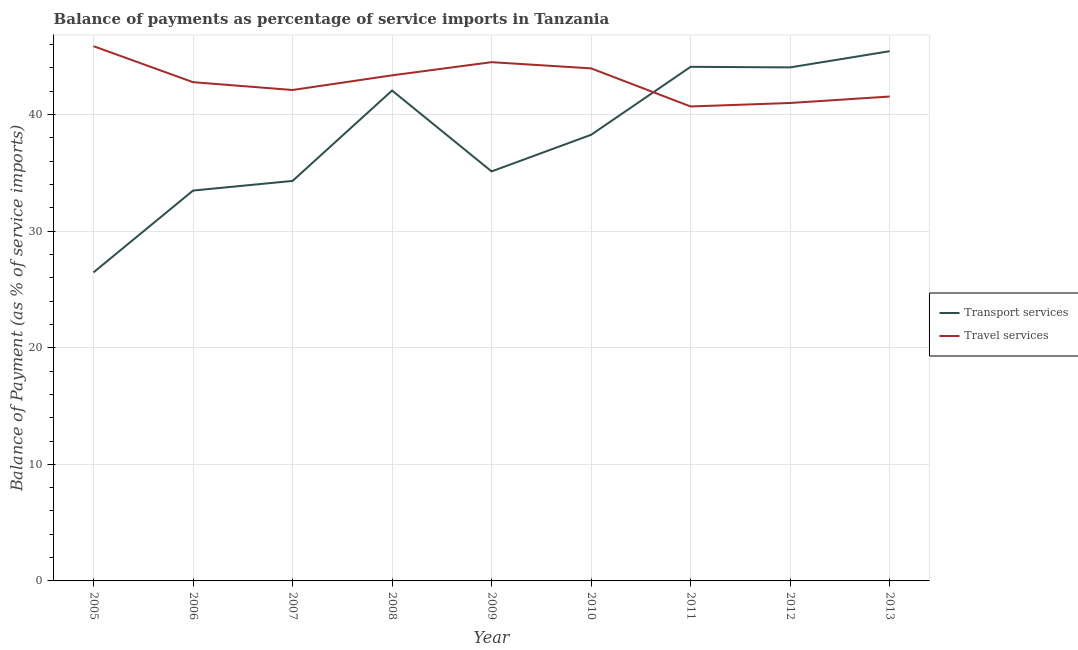Does the line corresponding to balance of payments of transport services intersect with the line corresponding to balance of payments of travel services?
Keep it short and to the point. Yes. Is the number of lines equal to the number of legend labels?
Give a very brief answer. Yes. What is the balance of payments of travel services in 2012?
Offer a very short reply. 40.99. Across all years, what is the maximum balance of payments of transport services?
Provide a short and direct response. 45.44. Across all years, what is the minimum balance of payments of transport services?
Ensure brevity in your answer.  26.47. In which year was the balance of payments of travel services maximum?
Ensure brevity in your answer.  2005. In which year was the balance of payments of transport services minimum?
Your answer should be compact. 2005. What is the total balance of payments of transport services in the graph?
Offer a terse response. 343.3. What is the difference between the balance of payments of transport services in 2007 and that in 2013?
Keep it short and to the point. -11.13. What is the difference between the balance of payments of transport services in 2007 and the balance of payments of travel services in 2011?
Your answer should be compact. -6.39. What is the average balance of payments of travel services per year?
Ensure brevity in your answer.  42.87. In the year 2011, what is the difference between the balance of payments of transport services and balance of payments of travel services?
Provide a short and direct response. 3.4. What is the ratio of the balance of payments of travel services in 2012 to that in 2013?
Give a very brief answer. 0.99. Is the balance of payments of travel services in 2011 less than that in 2013?
Offer a very short reply. Yes. Is the difference between the balance of payments of travel services in 2011 and 2013 greater than the difference between the balance of payments of transport services in 2011 and 2013?
Keep it short and to the point. Yes. What is the difference between the highest and the second highest balance of payments of transport services?
Your answer should be compact. 1.34. What is the difference between the highest and the lowest balance of payments of transport services?
Your answer should be very brief. 18.97. In how many years, is the balance of payments of travel services greater than the average balance of payments of travel services taken over all years?
Make the answer very short. 4. What is the difference between two consecutive major ticks on the Y-axis?
Offer a very short reply. 10. Does the graph contain any zero values?
Your answer should be very brief. No. Does the graph contain grids?
Keep it short and to the point. Yes. How many legend labels are there?
Provide a succinct answer. 2. What is the title of the graph?
Give a very brief answer. Balance of payments as percentage of service imports in Tanzania. Does "Unregistered firms" appear as one of the legend labels in the graph?
Provide a short and direct response. No. What is the label or title of the Y-axis?
Offer a terse response. Balance of Payment (as % of service imports). What is the Balance of Payment (as % of service imports) in Transport services in 2005?
Offer a terse response. 26.47. What is the Balance of Payment (as % of service imports) in Travel services in 2005?
Offer a very short reply. 45.87. What is the Balance of Payment (as % of service imports) in Transport services in 2006?
Your answer should be compact. 33.48. What is the Balance of Payment (as % of service imports) of Travel services in 2006?
Make the answer very short. 42.78. What is the Balance of Payment (as % of service imports) in Transport services in 2007?
Offer a terse response. 34.31. What is the Balance of Payment (as % of service imports) in Travel services in 2007?
Your answer should be very brief. 42.11. What is the Balance of Payment (as % of service imports) in Transport services in 2008?
Make the answer very short. 42.06. What is the Balance of Payment (as % of service imports) of Travel services in 2008?
Provide a succinct answer. 43.37. What is the Balance of Payment (as % of service imports) of Transport services in 2009?
Keep it short and to the point. 35.13. What is the Balance of Payment (as % of service imports) in Travel services in 2009?
Your answer should be very brief. 44.5. What is the Balance of Payment (as % of service imports) in Transport services in 2010?
Your answer should be very brief. 38.27. What is the Balance of Payment (as % of service imports) of Travel services in 2010?
Give a very brief answer. 43.96. What is the Balance of Payment (as % of service imports) of Transport services in 2011?
Ensure brevity in your answer.  44.1. What is the Balance of Payment (as % of service imports) of Travel services in 2011?
Provide a succinct answer. 40.7. What is the Balance of Payment (as % of service imports) of Transport services in 2012?
Your answer should be compact. 44.05. What is the Balance of Payment (as % of service imports) in Travel services in 2012?
Give a very brief answer. 40.99. What is the Balance of Payment (as % of service imports) in Transport services in 2013?
Your answer should be very brief. 45.44. What is the Balance of Payment (as % of service imports) in Travel services in 2013?
Your answer should be very brief. 41.55. Across all years, what is the maximum Balance of Payment (as % of service imports) in Transport services?
Your answer should be very brief. 45.44. Across all years, what is the maximum Balance of Payment (as % of service imports) of Travel services?
Your answer should be very brief. 45.87. Across all years, what is the minimum Balance of Payment (as % of service imports) of Transport services?
Keep it short and to the point. 26.47. Across all years, what is the minimum Balance of Payment (as % of service imports) in Travel services?
Provide a short and direct response. 40.7. What is the total Balance of Payment (as % of service imports) in Transport services in the graph?
Give a very brief answer. 343.3. What is the total Balance of Payment (as % of service imports) in Travel services in the graph?
Make the answer very short. 385.82. What is the difference between the Balance of Payment (as % of service imports) of Transport services in 2005 and that in 2006?
Your answer should be very brief. -7.02. What is the difference between the Balance of Payment (as % of service imports) in Travel services in 2005 and that in 2006?
Offer a terse response. 3.09. What is the difference between the Balance of Payment (as % of service imports) of Transport services in 2005 and that in 2007?
Ensure brevity in your answer.  -7.84. What is the difference between the Balance of Payment (as % of service imports) of Travel services in 2005 and that in 2007?
Your response must be concise. 3.76. What is the difference between the Balance of Payment (as % of service imports) of Transport services in 2005 and that in 2008?
Offer a very short reply. -15.6. What is the difference between the Balance of Payment (as % of service imports) of Travel services in 2005 and that in 2008?
Keep it short and to the point. 2.5. What is the difference between the Balance of Payment (as % of service imports) of Transport services in 2005 and that in 2009?
Your answer should be compact. -8.66. What is the difference between the Balance of Payment (as % of service imports) of Travel services in 2005 and that in 2009?
Provide a short and direct response. 1.37. What is the difference between the Balance of Payment (as % of service imports) of Transport services in 2005 and that in 2010?
Make the answer very short. -11.8. What is the difference between the Balance of Payment (as % of service imports) of Travel services in 2005 and that in 2010?
Your response must be concise. 1.9. What is the difference between the Balance of Payment (as % of service imports) in Transport services in 2005 and that in 2011?
Keep it short and to the point. -17.63. What is the difference between the Balance of Payment (as % of service imports) in Travel services in 2005 and that in 2011?
Provide a succinct answer. 5.17. What is the difference between the Balance of Payment (as % of service imports) of Transport services in 2005 and that in 2012?
Provide a succinct answer. -17.58. What is the difference between the Balance of Payment (as % of service imports) of Travel services in 2005 and that in 2012?
Make the answer very short. 4.87. What is the difference between the Balance of Payment (as % of service imports) in Transport services in 2005 and that in 2013?
Offer a terse response. -18.97. What is the difference between the Balance of Payment (as % of service imports) in Travel services in 2005 and that in 2013?
Ensure brevity in your answer.  4.32. What is the difference between the Balance of Payment (as % of service imports) in Transport services in 2006 and that in 2007?
Provide a short and direct response. -0.83. What is the difference between the Balance of Payment (as % of service imports) in Travel services in 2006 and that in 2007?
Your answer should be very brief. 0.67. What is the difference between the Balance of Payment (as % of service imports) of Transport services in 2006 and that in 2008?
Make the answer very short. -8.58. What is the difference between the Balance of Payment (as % of service imports) in Travel services in 2006 and that in 2008?
Provide a short and direct response. -0.59. What is the difference between the Balance of Payment (as % of service imports) in Transport services in 2006 and that in 2009?
Give a very brief answer. -1.64. What is the difference between the Balance of Payment (as % of service imports) of Travel services in 2006 and that in 2009?
Offer a very short reply. -1.72. What is the difference between the Balance of Payment (as % of service imports) of Transport services in 2006 and that in 2010?
Offer a terse response. -4.78. What is the difference between the Balance of Payment (as % of service imports) of Travel services in 2006 and that in 2010?
Your answer should be compact. -1.18. What is the difference between the Balance of Payment (as % of service imports) in Transport services in 2006 and that in 2011?
Provide a short and direct response. -10.61. What is the difference between the Balance of Payment (as % of service imports) in Travel services in 2006 and that in 2011?
Give a very brief answer. 2.08. What is the difference between the Balance of Payment (as % of service imports) in Transport services in 2006 and that in 2012?
Keep it short and to the point. -10.56. What is the difference between the Balance of Payment (as % of service imports) in Travel services in 2006 and that in 2012?
Your answer should be very brief. 1.78. What is the difference between the Balance of Payment (as % of service imports) in Transport services in 2006 and that in 2013?
Ensure brevity in your answer.  -11.95. What is the difference between the Balance of Payment (as % of service imports) of Travel services in 2006 and that in 2013?
Your answer should be very brief. 1.23. What is the difference between the Balance of Payment (as % of service imports) of Transport services in 2007 and that in 2008?
Your answer should be compact. -7.75. What is the difference between the Balance of Payment (as % of service imports) of Travel services in 2007 and that in 2008?
Your response must be concise. -1.26. What is the difference between the Balance of Payment (as % of service imports) in Transport services in 2007 and that in 2009?
Your response must be concise. -0.82. What is the difference between the Balance of Payment (as % of service imports) in Travel services in 2007 and that in 2009?
Your answer should be compact. -2.39. What is the difference between the Balance of Payment (as % of service imports) of Transport services in 2007 and that in 2010?
Your response must be concise. -3.96. What is the difference between the Balance of Payment (as % of service imports) of Travel services in 2007 and that in 2010?
Your response must be concise. -1.85. What is the difference between the Balance of Payment (as % of service imports) of Transport services in 2007 and that in 2011?
Your response must be concise. -9.79. What is the difference between the Balance of Payment (as % of service imports) in Travel services in 2007 and that in 2011?
Provide a short and direct response. 1.41. What is the difference between the Balance of Payment (as % of service imports) in Transport services in 2007 and that in 2012?
Your answer should be compact. -9.74. What is the difference between the Balance of Payment (as % of service imports) of Travel services in 2007 and that in 2012?
Your response must be concise. 1.11. What is the difference between the Balance of Payment (as % of service imports) in Transport services in 2007 and that in 2013?
Your answer should be compact. -11.13. What is the difference between the Balance of Payment (as % of service imports) of Travel services in 2007 and that in 2013?
Provide a succinct answer. 0.56. What is the difference between the Balance of Payment (as % of service imports) in Transport services in 2008 and that in 2009?
Ensure brevity in your answer.  6.94. What is the difference between the Balance of Payment (as % of service imports) of Travel services in 2008 and that in 2009?
Offer a very short reply. -1.13. What is the difference between the Balance of Payment (as % of service imports) of Transport services in 2008 and that in 2010?
Give a very brief answer. 3.8. What is the difference between the Balance of Payment (as % of service imports) in Travel services in 2008 and that in 2010?
Offer a terse response. -0.6. What is the difference between the Balance of Payment (as % of service imports) of Transport services in 2008 and that in 2011?
Provide a succinct answer. -2.03. What is the difference between the Balance of Payment (as % of service imports) of Travel services in 2008 and that in 2011?
Offer a very short reply. 2.67. What is the difference between the Balance of Payment (as % of service imports) of Transport services in 2008 and that in 2012?
Offer a terse response. -1.98. What is the difference between the Balance of Payment (as % of service imports) of Travel services in 2008 and that in 2012?
Give a very brief answer. 2.37. What is the difference between the Balance of Payment (as % of service imports) in Transport services in 2008 and that in 2013?
Ensure brevity in your answer.  -3.37. What is the difference between the Balance of Payment (as % of service imports) of Travel services in 2008 and that in 2013?
Ensure brevity in your answer.  1.82. What is the difference between the Balance of Payment (as % of service imports) of Transport services in 2009 and that in 2010?
Make the answer very short. -3.14. What is the difference between the Balance of Payment (as % of service imports) in Travel services in 2009 and that in 2010?
Make the answer very short. 0.53. What is the difference between the Balance of Payment (as % of service imports) in Transport services in 2009 and that in 2011?
Provide a succinct answer. -8.97. What is the difference between the Balance of Payment (as % of service imports) of Travel services in 2009 and that in 2011?
Ensure brevity in your answer.  3.8. What is the difference between the Balance of Payment (as % of service imports) in Transport services in 2009 and that in 2012?
Provide a short and direct response. -8.92. What is the difference between the Balance of Payment (as % of service imports) of Travel services in 2009 and that in 2012?
Give a very brief answer. 3.5. What is the difference between the Balance of Payment (as % of service imports) in Transport services in 2009 and that in 2013?
Ensure brevity in your answer.  -10.31. What is the difference between the Balance of Payment (as % of service imports) in Travel services in 2009 and that in 2013?
Keep it short and to the point. 2.95. What is the difference between the Balance of Payment (as % of service imports) in Transport services in 2010 and that in 2011?
Make the answer very short. -5.83. What is the difference between the Balance of Payment (as % of service imports) of Travel services in 2010 and that in 2011?
Provide a short and direct response. 3.27. What is the difference between the Balance of Payment (as % of service imports) in Transport services in 2010 and that in 2012?
Ensure brevity in your answer.  -5.78. What is the difference between the Balance of Payment (as % of service imports) of Travel services in 2010 and that in 2012?
Your answer should be compact. 2.97. What is the difference between the Balance of Payment (as % of service imports) of Transport services in 2010 and that in 2013?
Give a very brief answer. -7.17. What is the difference between the Balance of Payment (as % of service imports) of Travel services in 2010 and that in 2013?
Make the answer very short. 2.42. What is the difference between the Balance of Payment (as % of service imports) of Transport services in 2011 and that in 2012?
Your response must be concise. 0.05. What is the difference between the Balance of Payment (as % of service imports) of Travel services in 2011 and that in 2012?
Your response must be concise. -0.3. What is the difference between the Balance of Payment (as % of service imports) in Transport services in 2011 and that in 2013?
Make the answer very short. -1.34. What is the difference between the Balance of Payment (as % of service imports) in Travel services in 2011 and that in 2013?
Make the answer very short. -0.85. What is the difference between the Balance of Payment (as % of service imports) of Transport services in 2012 and that in 2013?
Offer a very short reply. -1.39. What is the difference between the Balance of Payment (as % of service imports) of Travel services in 2012 and that in 2013?
Offer a terse response. -0.55. What is the difference between the Balance of Payment (as % of service imports) of Transport services in 2005 and the Balance of Payment (as % of service imports) of Travel services in 2006?
Your response must be concise. -16.31. What is the difference between the Balance of Payment (as % of service imports) in Transport services in 2005 and the Balance of Payment (as % of service imports) in Travel services in 2007?
Your answer should be compact. -15.64. What is the difference between the Balance of Payment (as % of service imports) in Transport services in 2005 and the Balance of Payment (as % of service imports) in Travel services in 2008?
Provide a short and direct response. -16.9. What is the difference between the Balance of Payment (as % of service imports) of Transport services in 2005 and the Balance of Payment (as % of service imports) of Travel services in 2009?
Ensure brevity in your answer.  -18.03. What is the difference between the Balance of Payment (as % of service imports) in Transport services in 2005 and the Balance of Payment (as % of service imports) in Travel services in 2010?
Make the answer very short. -17.5. What is the difference between the Balance of Payment (as % of service imports) in Transport services in 2005 and the Balance of Payment (as % of service imports) in Travel services in 2011?
Offer a very short reply. -14.23. What is the difference between the Balance of Payment (as % of service imports) of Transport services in 2005 and the Balance of Payment (as % of service imports) of Travel services in 2012?
Provide a succinct answer. -14.53. What is the difference between the Balance of Payment (as % of service imports) in Transport services in 2005 and the Balance of Payment (as % of service imports) in Travel services in 2013?
Keep it short and to the point. -15.08. What is the difference between the Balance of Payment (as % of service imports) in Transport services in 2006 and the Balance of Payment (as % of service imports) in Travel services in 2007?
Offer a terse response. -8.63. What is the difference between the Balance of Payment (as % of service imports) in Transport services in 2006 and the Balance of Payment (as % of service imports) in Travel services in 2008?
Your answer should be very brief. -9.88. What is the difference between the Balance of Payment (as % of service imports) in Transport services in 2006 and the Balance of Payment (as % of service imports) in Travel services in 2009?
Your response must be concise. -11.01. What is the difference between the Balance of Payment (as % of service imports) of Transport services in 2006 and the Balance of Payment (as % of service imports) of Travel services in 2010?
Provide a short and direct response. -10.48. What is the difference between the Balance of Payment (as % of service imports) of Transport services in 2006 and the Balance of Payment (as % of service imports) of Travel services in 2011?
Make the answer very short. -7.21. What is the difference between the Balance of Payment (as % of service imports) of Transport services in 2006 and the Balance of Payment (as % of service imports) of Travel services in 2012?
Offer a terse response. -7.51. What is the difference between the Balance of Payment (as % of service imports) in Transport services in 2006 and the Balance of Payment (as % of service imports) in Travel services in 2013?
Your answer should be compact. -8.07. What is the difference between the Balance of Payment (as % of service imports) in Transport services in 2007 and the Balance of Payment (as % of service imports) in Travel services in 2008?
Keep it short and to the point. -9.06. What is the difference between the Balance of Payment (as % of service imports) in Transport services in 2007 and the Balance of Payment (as % of service imports) in Travel services in 2009?
Your response must be concise. -10.19. What is the difference between the Balance of Payment (as % of service imports) of Transport services in 2007 and the Balance of Payment (as % of service imports) of Travel services in 2010?
Keep it short and to the point. -9.65. What is the difference between the Balance of Payment (as % of service imports) of Transport services in 2007 and the Balance of Payment (as % of service imports) of Travel services in 2011?
Keep it short and to the point. -6.39. What is the difference between the Balance of Payment (as % of service imports) in Transport services in 2007 and the Balance of Payment (as % of service imports) in Travel services in 2012?
Provide a succinct answer. -6.68. What is the difference between the Balance of Payment (as % of service imports) in Transport services in 2007 and the Balance of Payment (as % of service imports) in Travel services in 2013?
Provide a succinct answer. -7.24. What is the difference between the Balance of Payment (as % of service imports) of Transport services in 2008 and the Balance of Payment (as % of service imports) of Travel services in 2009?
Offer a very short reply. -2.43. What is the difference between the Balance of Payment (as % of service imports) of Transport services in 2008 and the Balance of Payment (as % of service imports) of Travel services in 2010?
Provide a succinct answer. -1.9. What is the difference between the Balance of Payment (as % of service imports) of Transport services in 2008 and the Balance of Payment (as % of service imports) of Travel services in 2011?
Keep it short and to the point. 1.37. What is the difference between the Balance of Payment (as % of service imports) of Transport services in 2008 and the Balance of Payment (as % of service imports) of Travel services in 2012?
Give a very brief answer. 1.07. What is the difference between the Balance of Payment (as % of service imports) of Transport services in 2008 and the Balance of Payment (as % of service imports) of Travel services in 2013?
Provide a short and direct response. 0.51. What is the difference between the Balance of Payment (as % of service imports) in Transport services in 2009 and the Balance of Payment (as % of service imports) in Travel services in 2010?
Provide a succinct answer. -8.84. What is the difference between the Balance of Payment (as % of service imports) of Transport services in 2009 and the Balance of Payment (as % of service imports) of Travel services in 2011?
Offer a very short reply. -5.57. What is the difference between the Balance of Payment (as % of service imports) of Transport services in 2009 and the Balance of Payment (as % of service imports) of Travel services in 2012?
Your answer should be very brief. -5.87. What is the difference between the Balance of Payment (as % of service imports) of Transport services in 2009 and the Balance of Payment (as % of service imports) of Travel services in 2013?
Provide a short and direct response. -6.42. What is the difference between the Balance of Payment (as % of service imports) of Transport services in 2010 and the Balance of Payment (as % of service imports) of Travel services in 2011?
Your response must be concise. -2.43. What is the difference between the Balance of Payment (as % of service imports) of Transport services in 2010 and the Balance of Payment (as % of service imports) of Travel services in 2012?
Offer a terse response. -2.73. What is the difference between the Balance of Payment (as % of service imports) in Transport services in 2010 and the Balance of Payment (as % of service imports) in Travel services in 2013?
Your response must be concise. -3.28. What is the difference between the Balance of Payment (as % of service imports) in Transport services in 2011 and the Balance of Payment (as % of service imports) in Travel services in 2012?
Your answer should be compact. 3.1. What is the difference between the Balance of Payment (as % of service imports) of Transport services in 2011 and the Balance of Payment (as % of service imports) of Travel services in 2013?
Offer a very short reply. 2.55. What is the difference between the Balance of Payment (as % of service imports) in Transport services in 2012 and the Balance of Payment (as % of service imports) in Travel services in 2013?
Your answer should be compact. 2.5. What is the average Balance of Payment (as % of service imports) in Transport services per year?
Provide a succinct answer. 38.14. What is the average Balance of Payment (as % of service imports) of Travel services per year?
Keep it short and to the point. 42.87. In the year 2005, what is the difference between the Balance of Payment (as % of service imports) of Transport services and Balance of Payment (as % of service imports) of Travel services?
Provide a succinct answer. -19.4. In the year 2006, what is the difference between the Balance of Payment (as % of service imports) of Transport services and Balance of Payment (as % of service imports) of Travel services?
Your answer should be very brief. -9.3. In the year 2007, what is the difference between the Balance of Payment (as % of service imports) of Transport services and Balance of Payment (as % of service imports) of Travel services?
Your answer should be compact. -7.8. In the year 2008, what is the difference between the Balance of Payment (as % of service imports) in Transport services and Balance of Payment (as % of service imports) in Travel services?
Offer a very short reply. -1.3. In the year 2009, what is the difference between the Balance of Payment (as % of service imports) of Transport services and Balance of Payment (as % of service imports) of Travel services?
Your answer should be very brief. -9.37. In the year 2010, what is the difference between the Balance of Payment (as % of service imports) of Transport services and Balance of Payment (as % of service imports) of Travel services?
Offer a very short reply. -5.7. In the year 2011, what is the difference between the Balance of Payment (as % of service imports) of Transport services and Balance of Payment (as % of service imports) of Travel services?
Ensure brevity in your answer.  3.4. In the year 2012, what is the difference between the Balance of Payment (as % of service imports) in Transport services and Balance of Payment (as % of service imports) in Travel services?
Keep it short and to the point. 3.05. In the year 2013, what is the difference between the Balance of Payment (as % of service imports) of Transport services and Balance of Payment (as % of service imports) of Travel services?
Provide a succinct answer. 3.89. What is the ratio of the Balance of Payment (as % of service imports) in Transport services in 2005 to that in 2006?
Keep it short and to the point. 0.79. What is the ratio of the Balance of Payment (as % of service imports) of Travel services in 2005 to that in 2006?
Your answer should be compact. 1.07. What is the ratio of the Balance of Payment (as % of service imports) of Transport services in 2005 to that in 2007?
Your answer should be compact. 0.77. What is the ratio of the Balance of Payment (as % of service imports) in Travel services in 2005 to that in 2007?
Keep it short and to the point. 1.09. What is the ratio of the Balance of Payment (as % of service imports) of Transport services in 2005 to that in 2008?
Ensure brevity in your answer.  0.63. What is the ratio of the Balance of Payment (as % of service imports) in Travel services in 2005 to that in 2008?
Give a very brief answer. 1.06. What is the ratio of the Balance of Payment (as % of service imports) of Transport services in 2005 to that in 2009?
Provide a succinct answer. 0.75. What is the ratio of the Balance of Payment (as % of service imports) of Travel services in 2005 to that in 2009?
Your answer should be compact. 1.03. What is the ratio of the Balance of Payment (as % of service imports) of Transport services in 2005 to that in 2010?
Keep it short and to the point. 0.69. What is the ratio of the Balance of Payment (as % of service imports) in Travel services in 2005 to that in 2010?
Your answer should be compact. 1.04. What is the ratio of the Balance of Payment (as % of service imports) in Transport services in 2005 to that in 2011?
Offer a very short reply. 0.6. What is the ratio of the Balance of Payment (as % of service imports) of Travel services in 2005 to that in 2011?
Ensure brevity in your answer.  1.13. What is the ratio of the Balance of Payment (as % of service imports) of Transport services in 2005 to that in 2012?
Keep it short and to the point. 0.6. What is the ratio of the Balance of Payment (as % of service imports) of Travel services in 2005 to that in 2012?
Offer a very short reply. 1.12. What is the ratio of the Balance of Payment (as % of service imports) of Transport services in 2005 to that in 2013?
Your response must be concise. 0.58. What is the ratio of the Balance of Payment (as % of service imports) of Travel services in 2005 to that in 2013?
Give a very brief answer. 1.1. What is the ratio of the Balance of Payment (as % of service imports) of Transport services in 2006 to that in 2007?
Provide a succinct answer. 0.98. What is the ratio of the Balance of Payment (as % of service imports) in Travel services in 2006 to that in 2007?
Give a very brief answer. 1.02. What is the ratio of the Balance of Payment (as % of service imports) in Transport services in 2006 to that in 2008?
Provide a short and direct response. 0.8. What is the ratio of the Balance of Payment (as % of service imports) of Travel services in 2006 to that in 2008?
Provide a succinct answer. 0.99. What is the ratio of the Balance of Payment (as % of service imports) of Transport services in 2006 to that in 2009?
Keep it short and to the point. 0.95. What is the ratio of the Balance of Payment (as % of service imports) of Travel services in 2006 to that in 2009?
Provide a succinct answer. 0.96. What is the ratio of the Balance of Payment (as % of service imports) of Travel services in 2006 to that in 2010?
Give a very brief answer. 0.97. What is the ratio of the Balance of Payment (as % of service imports) in Transport services in 2006 to that in 2011?
Give a very brief answer. 0.76. What is the ratio of the Balance of Payment (as % of service imports) in Travel services in 2006 to that in 2011?
Keep it short and to the point. 1.05. What is the ratio of the Balance of Payment (as % of service imports) in Transport services in 2006 to that in 2012?
Provide a succinct answer. 0.76. What is the ratio of the Balance of Payment (as % of service imports) in Travel services in 2006 to that in 2012?
Offer a very short reply. 1.04. What is the ratio of the Balance of Payment (as % of service imports) of Transport services in 2006 to that in 2013?
Your response must be concise. 0.74. What is the ratio of the Balance of Payment (as % of service imports) in Travel services in 2006 to that in 2013?
Your answer should be compact. 1.03. What is the ratio of the Balance of Payment (as % of service imports) of Transport services in 2007 to that in 2008?
Ensure brevity in your answer.  0.82. What is the ratio of the Balance of Payment (as % of service imports) in Transport services in 2007 to that in 2009?
Your answer should be very brief. 0.98. What is the ratio of the Balance of Payment (as % of service imports) in Travel services in 2007 to that in 2009?
Keep it short and to the point. 0.95. What is the ratio of the Balance of Payment (as % of service imports) of Transport services in 2007 to that in 2010?
Provide a short and direct response. 0.9. What is the ratio of the Balance of Payment (as % of service imports) of Travel services in 2007 to that in 2010?
Your answer should be compact. 0.96. What is the ratio of the Balance of Payment (as % of service imports) in Transport services in 2007 to that in 2011?
Provide a succinct answer. 0.78. What is the ratio of the Balance of Payment (as % of service imports) of Travel services in 2007 to that in 2011?
Provide a short and direct response. 1.03. What is the ratio of the Balance of Payment (as % of service imports) in Transport services in 2007 to that in 2012?
Give a very brief answer. 0.78. What is the ratio of the Balance of Payment (as % of service imports) in Travel services in 2007 to that in 2012?
Give a very brief answer. 1.03. What is the ratio of the Balance of Payment (as % of service imports) in Transport services in 2007 to that in 2013?
Offer a terse response. 0.76. What is the ratio of the Balance of Payment (as % of service imports) in Travel services in 2007 to that in 2013?
Give a very brief answer. 1.01. What is the ratio of the Balance of Payment (as % of service imports) in Transport services in 2008 to that in 2009?
Make the answer very short. 1.2. What is the ratio of the Balance of Payment (as % of service imports) in Travel services in 2008 to that in 2009?
Provide a short and direct response. 0.97. What is the ratio of the Balance of Payment (as % of service imports) in Transport services in 2008 to that in 2010?
Ensure brevity in your answer.  1.1. What is the ratio of the Balance of Payment (as % of service imports) in Travel services in 2008 to that in 2010?
Offer a terse response. 0.99. What is the ratio of the Balance of Payment (as % of service imports) in Transport services in 2008 to that in 2011?
Give a very brief answer. 0.95. What is the ratio of the Balance of Payment (as % of service imports) of Travel services in 2008 to that in 2011?
Make the answer very short. 1.07. What is the ratio of the Balance of Payment (as % of service imports) in Transport services in 2008 to that in 2012?
Provide a short and direct response. 0.95. What is the ratio of the Balance of Payment (as % of service imports) of Travel services in 2008 to that in 2012?
Provide a short and direct response. 1.06. What is the ratio of the Balance of Payment (as % of service imports) of Transport services in 2008 to that in 2013?
Provide a succinct answer. 0.93. What is the ratio of the Balance of Payment (as % of service imports) of Travel services in 2008 to that in 2013?
Give a very brief answer. 1.04. What is the ratio of the Balance of Payment (as % of service imports) of Transport services in 2009 to that in 2010?
Provide a short and direct response. 0.92. What is the ratio of the Balance of Payment (as % of service imports) in Travel services in 2009 to that in 2010?
Offer a very short reply. 1.01. What is the ratio of the Balance of Payment (as % of service imports) in Transport services in 2009 to that in 2011?
Your answer should be compact. 0.8. What is the ratio of the Balance of Payment (as % of service imports) of Travel services in 2009 to that in 2011?
Provide a succinct answer. 1.09. What is the ratio of the Balance of Payment (as % of service imports) in Transport services in 2009 to that in 2012?
Provide a succinct answer. 0.8. What is the ratio of the Balance of Payment (as % of service imports) of Travel services in 2009 to that in 2012?
Make the answer very short. 1.09. What is the ratio of the Balance of Payment (as % of service imports) of Transport services in 2009 to that in 2013?
Provide a short and direct response. 0.77. What is the ratio of the Balance of Payment (as % of service imports) of Travel services in 2009 to that in 2013?
Ensure brevity in your answer.  1.07. What is the ratio of the Balance of Payment (as % of service imports) in Transport services in 2010 to that in 2011?
Ensure brevity in your answer.  0.87. What is the ratio of the Balance of Payment (as % of service imports) of Travel services in 2010 to that in 2011?
Provide a short and direct response. 1.08. What is the ratio of the Balance of Payment (as % of service imports) in Transport services in 2010 to that in 2012?
Your answer should be compact. 0.87. What is the ratio of the Balance of Payment (as % of service imports) in Travel services in 2010 to that in 2012?
Ensure brevity in your answer.  1.07. What is the ratio of the Balance of Payment (as % of service imports) in Transport services in 2010 to that in 2013?
Make the answer very short. 0.84. What is the ratio of the Balance of Payment (as % of service imports) in Travel services in 2010 to that in 2013?
Provide a succinct answer. 1.06. What is the ratio of the Balance of Payment (as % of service imports) in Travel services in 2011 to that in 2012?
Make the answer very short. 0.99. What is the ratio of the Balance of Payment (as % of service imports) in Transport services in 2011 to that in 2013?
Your answer should be very brief. 0.97. What is the ratio of the Balance of Payment (as % of service imports) of Travel services in 2011 to that in 2013?
Offer a terse response. 0.98. What is the ratio of the Balance of Payment (as % of service imports) of Transport services in 2012 to that in 2013?
Provide a succinct answer. 0.97. What is the ratio of the Balance of Payment (as % of service imports) of Travel services in 2012 to that in 2013?
Provide a succinct answer. 0.99. What is the difference between the highest and the second highest Balance of Payment (as % of service imports) in Transport services?
Your response must be concise. 1.34. What is the difference between the highest and the second highest Balance of Payment (as % of service imports) of Travel services?
Your response must be concise. 1.37. What is the difference between the highest and the lowest Balance of Payment (as % of service imports) of Transport services?
Your answer should be compact. 18.97. What is the difference between the highest and the lowest Balance of Payment (as % of service imports) in Travel services?
Your response must be concise. 5.17. 